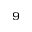<formula> <loc_0><loc_0><loc_500><loc_500>_ { 9 }</formula> 